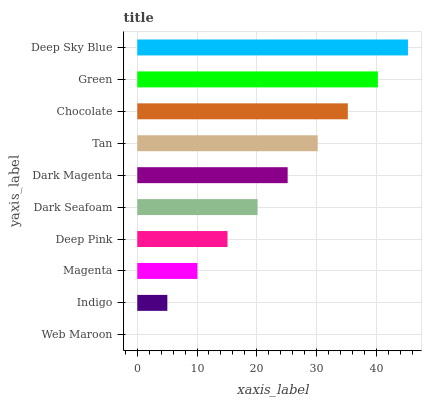Is Web Maroon the minimum?
Answer yes or no. Yes. Is Deep Sky Blue the maximum?
Answer yes or no. Yes. Is Indigo the minimum?
Answer yes or no. No. Is Indigo the maximum?
Answer yes or no. No. Is Indigo greater than Web Maroon?
Answer yes or no. Yes. Is Web Maroon less than Indigo?
Answer yes or no. Yes. Is Web Maroon greater than Indigo?
Answer yes or no. No. Is Indigo less than Web Maroon?
Answer yes or no. No. Is Dark Magenta the high median?
Answer yes or no. Yes. Is Dark Seafoam the low median?
Answer yes or no. Yes. Is Dark Seafoam the high median?
Answer yes or no. No. Is Dark Magenta the low median?
Answer yes or no. No. 